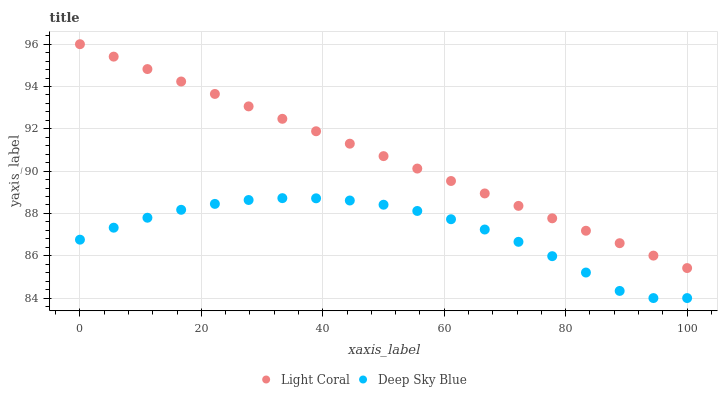Does Deep Sky Blue have the minimum area under the curve?
Answer yes or no. Yes. Does Light Coral have the maximum area under the curve?
Answer yes or no. Yes. Does Deep Sky Blue have the maximum area under the curve?
Answer yes or no. No. Is Light Coral the smoothest?
Answer yes or no. Yes. Is Deep Sky Blue the roughest?
Answer yes or no. Yes. Is Deep Sky Blue the smoothest?
Answer yes or no. No. Does Deep Sky Blue have the lowest value?
Answer yes or no. Yes. Does Light Coral have the highest value?
Answer yes or no. Yes. Does Deep Sky Blue have the highest value?
Answer yes or no. No. Is Deep Sky Blue less than Light Coral?
Answer yes or no. Yes. Is Light Coral greater than Deep Sky Blue?
Answer yes or no. Yes. Does Deep Sky Blue intersect Light Coral?
Answer yes or no. No. 